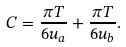Convert formula to latex. <formula><loc_0><loc_0><loc_500><loc_500>C = \frac { \pi T } { 6 u _ { a } } + \frac { \pi T } { 6 u _ { b } } .</formula> 